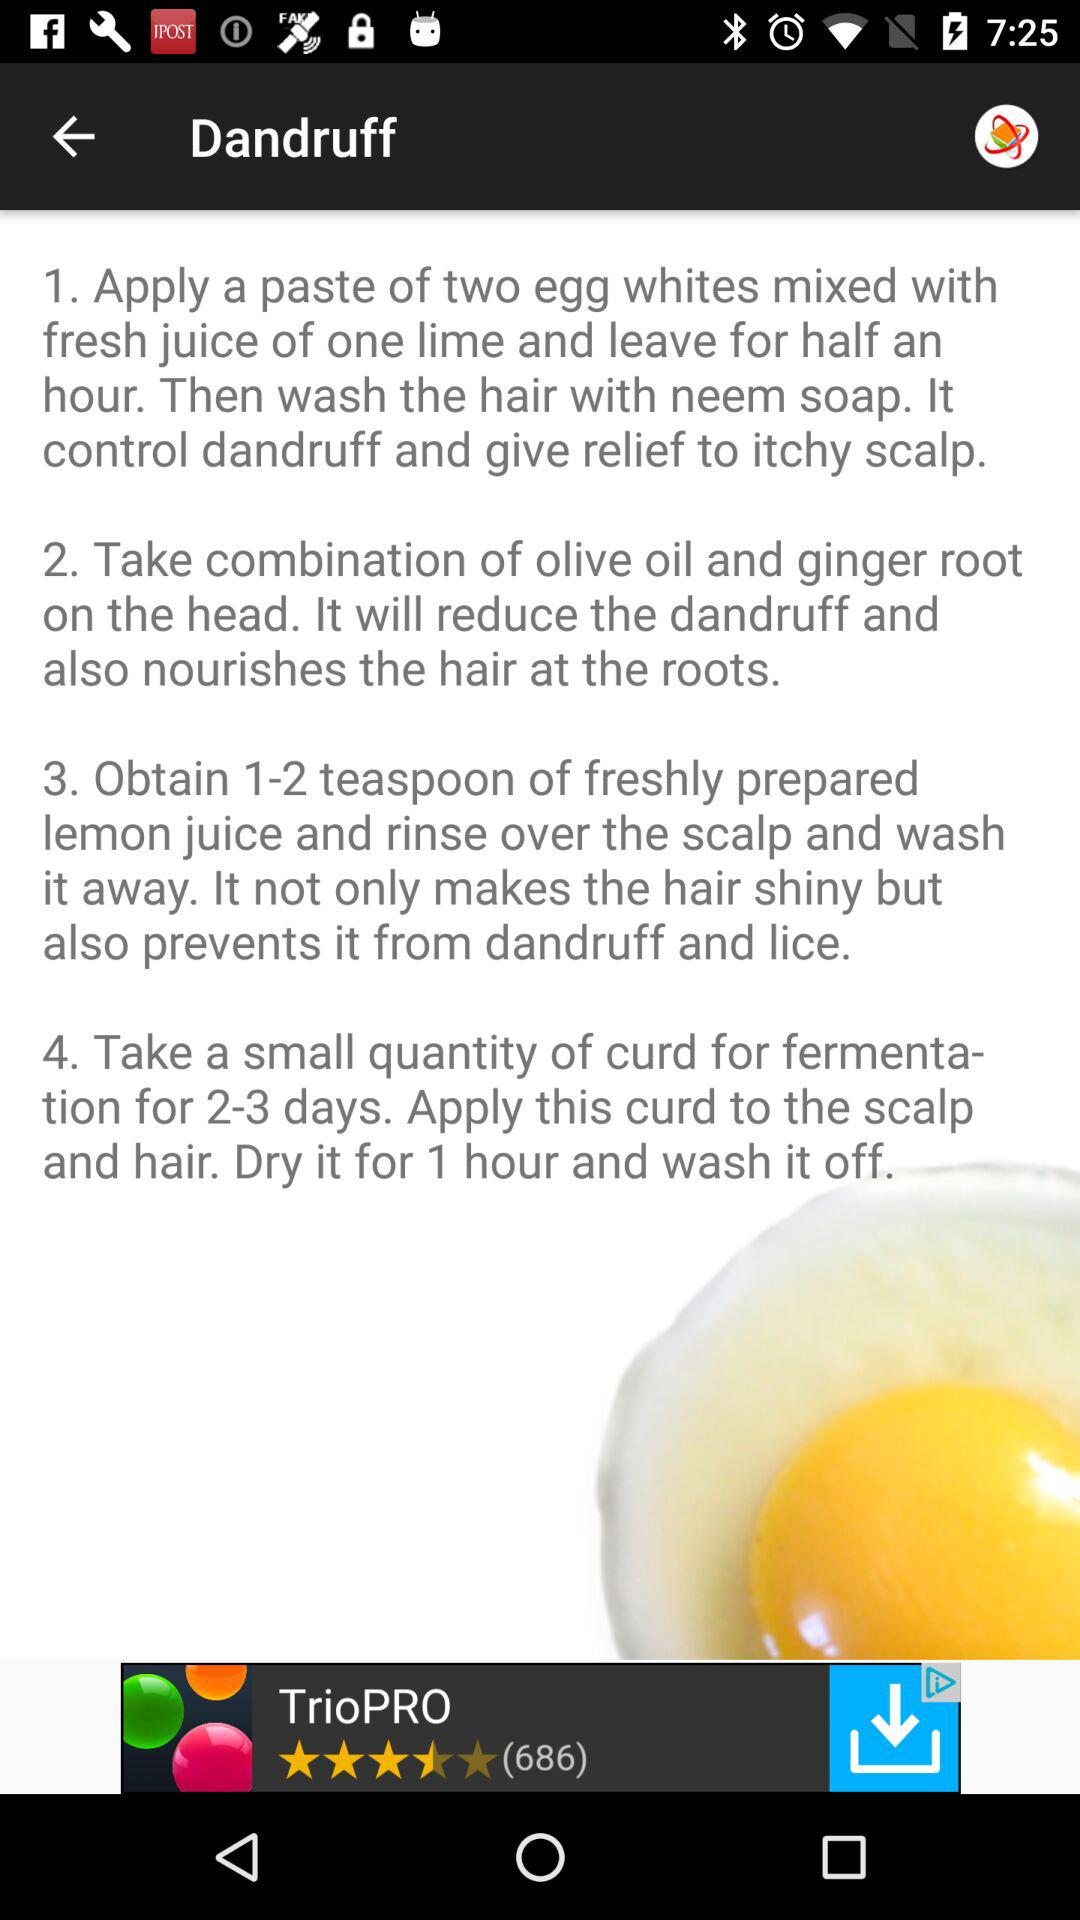What controls dandruff and gives relief to an itchy scalp? Dandruff and itchy scalp are treated by applying a paste of two egg whites mixed with the fresh juice of one lime and leaving it on for 30 minutes. Then wash the hair with neem soap. 